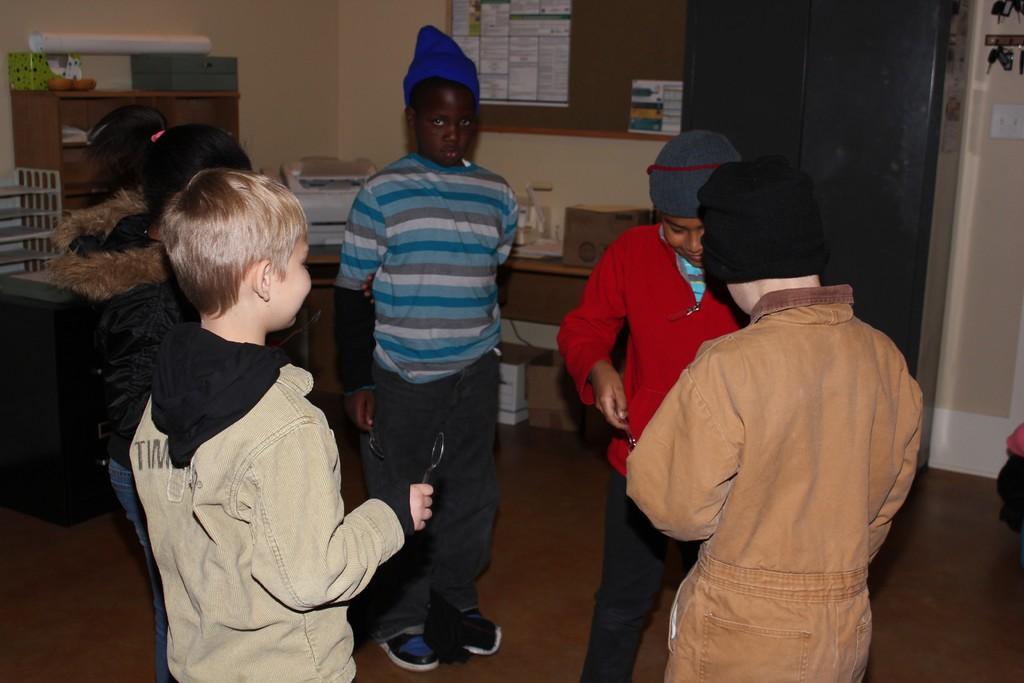How would you summarize this image in a sentence or two? In the center of the image we can see five kids and they are in different costumes. Among them, we can see three persons are wearing hats and two kids are smiling. In the background there is a wall, table, cupboard, white chart, board, boxes, shelves, posters, one switchboard and a few other objects. 